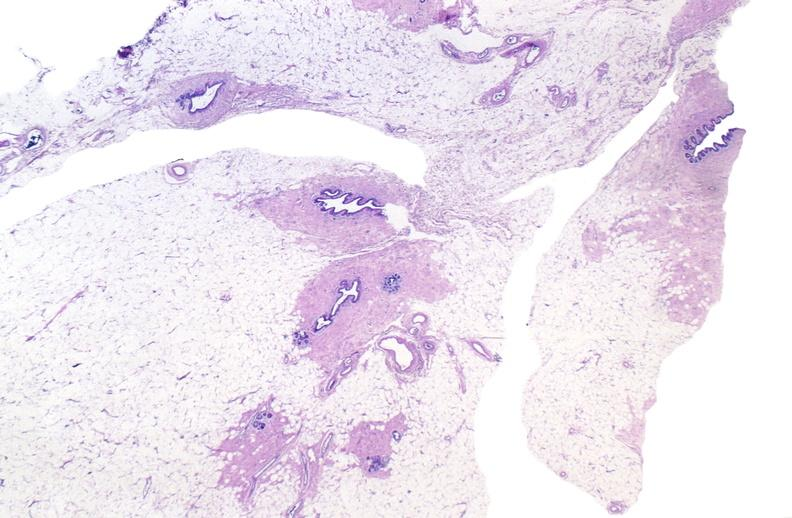does newborn cord around neck show normal breast?
Answer the question using a single word or phrase. No 